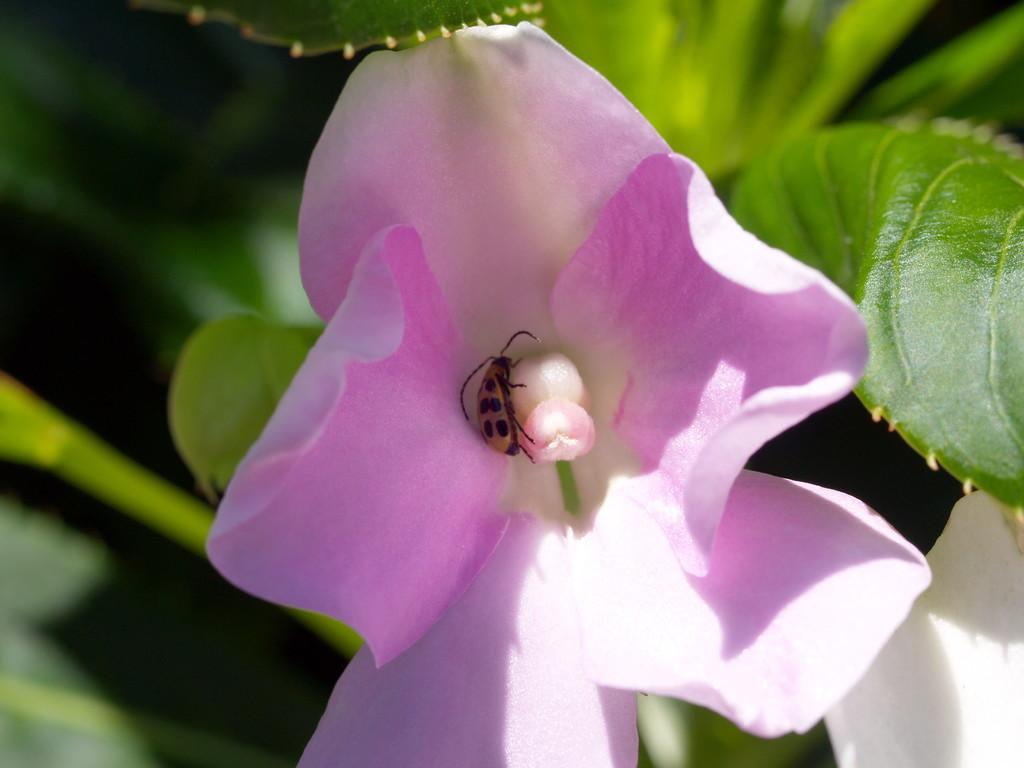What is the main subject of the image? There is a flower in the image. Is there anything else present on the flower? Yes, there is an insect on the flower. What can be seen in the background of the image? There are leaves visible in the background of the image. What type of bubble can be seen in the bedroom in the image? There is no bubble or bedroom present in the image; it features a flower with an insect and leaves in the background. 